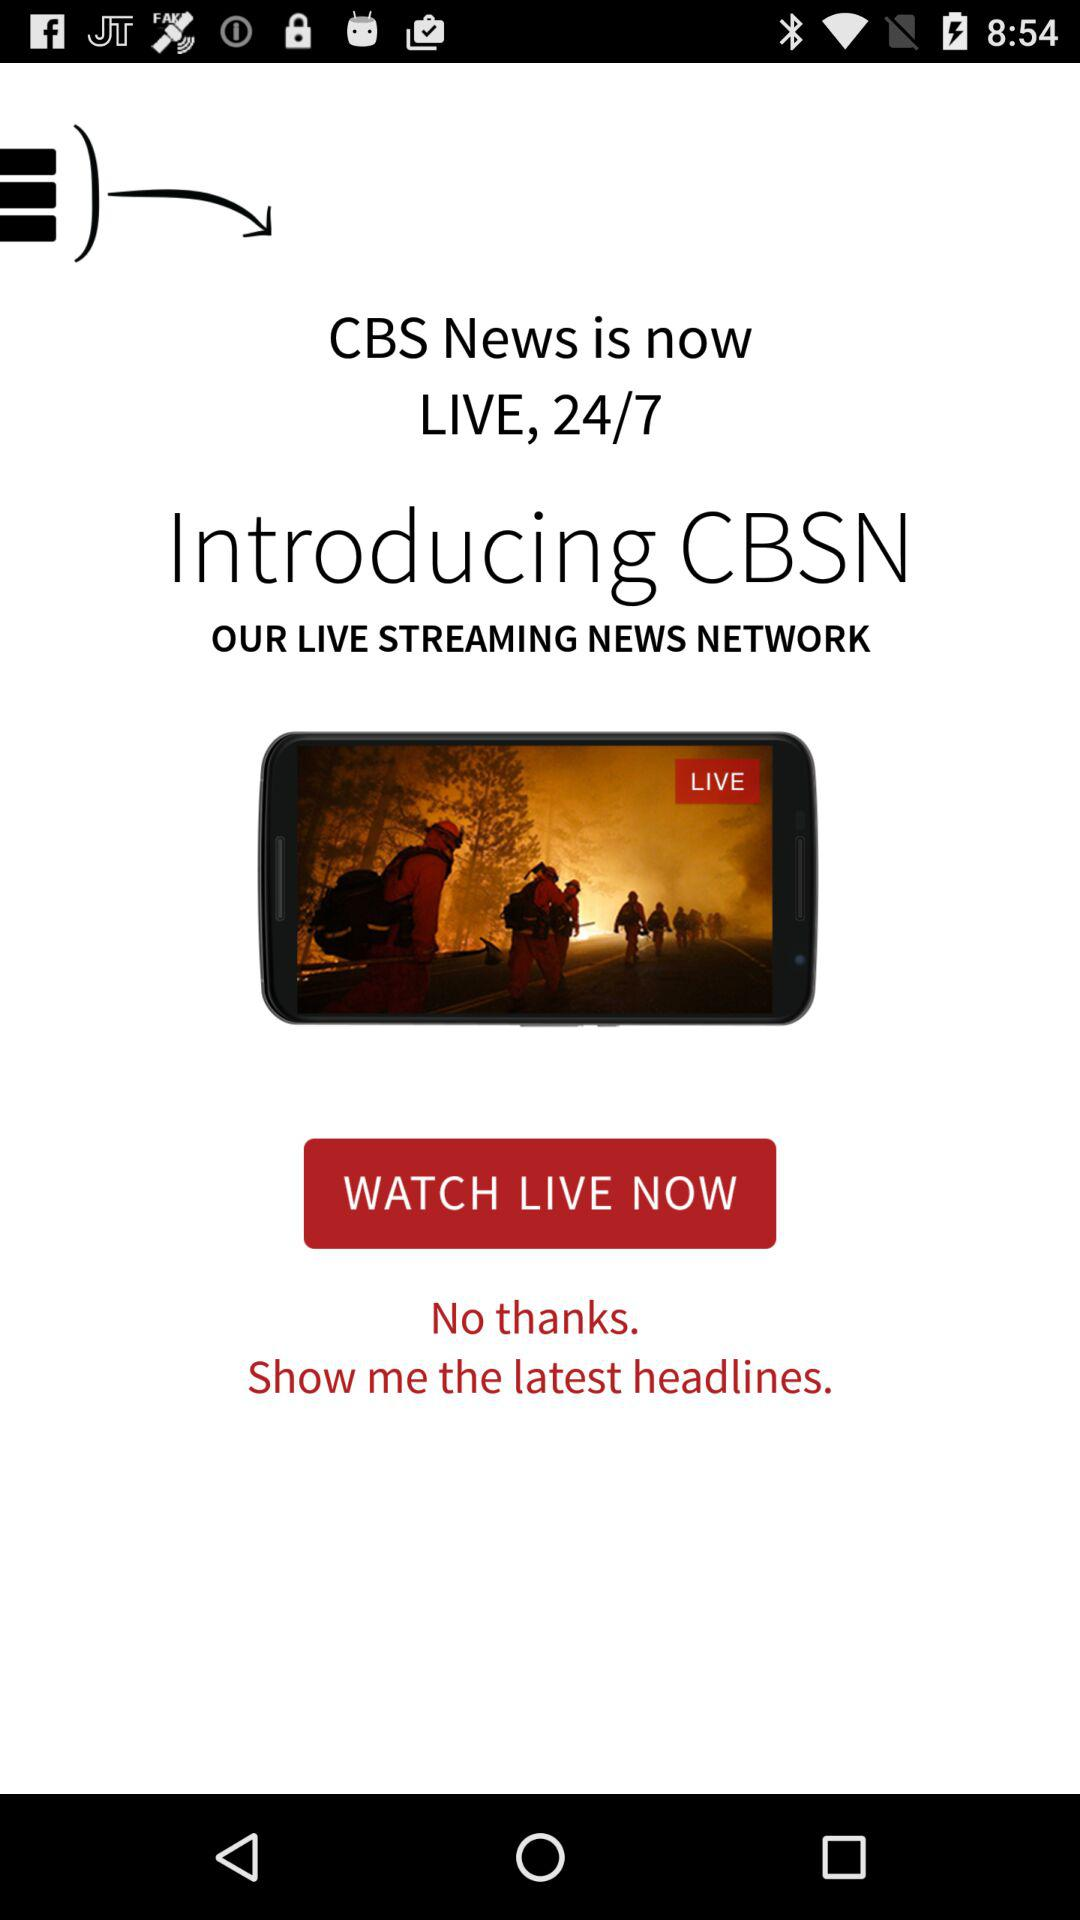How many hours does "CBS News" go live? "CBS News" goes live for 24 hours. 